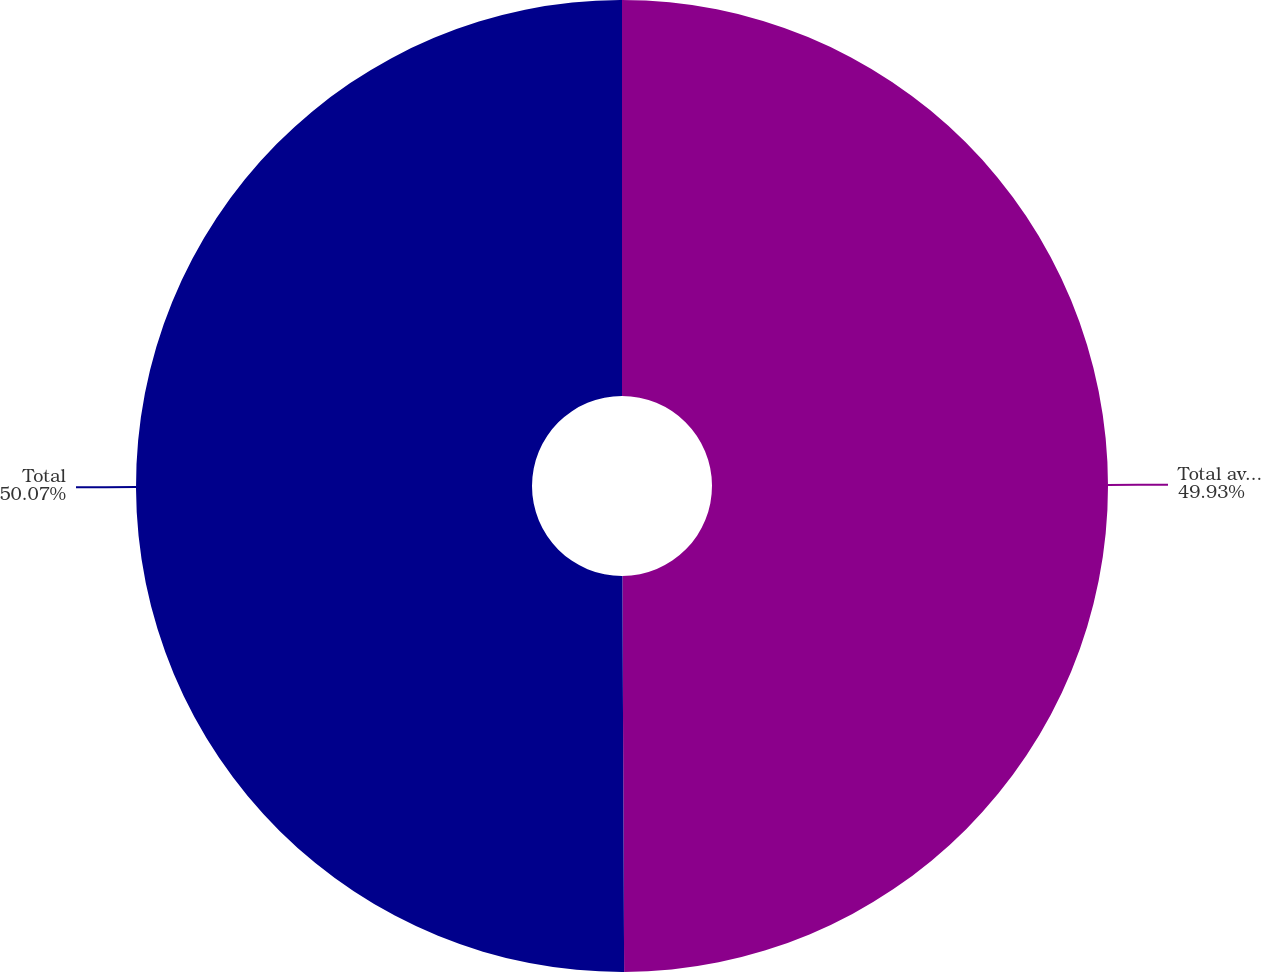Convert chart to OTSL. <chart><loc_0><loc_0><loc_500><loc_500><pie_chart><fcel>Total available-for-sale debt<fcel>Total<nl><fcel>49.93%<fcel>50.07%<nl></chart> 